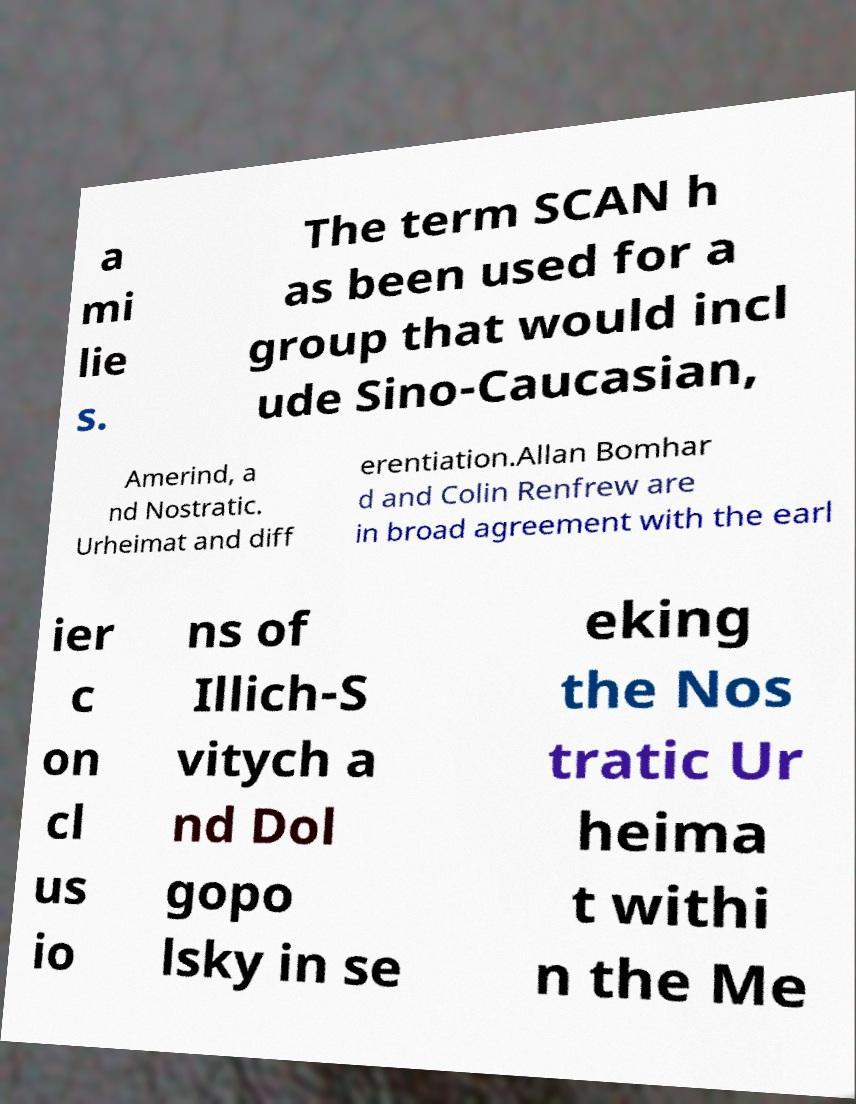There's text embedded in this image that I need extracted. Can you transcribe it verbatim? a mi lie s. The term SCAN h as been used for a group that would incl ude Sino-Caucasian, Amerind, a nd Nostratic. Urheimat and diff erentiation.Allan Bomhar d and Colin Renfrew are in broad agreement with the earl ier c on cl us io ns of Illich-S vitych a nd Dol gopo lsky in se eking the Nos tratic Ur heima t withi n the Me 